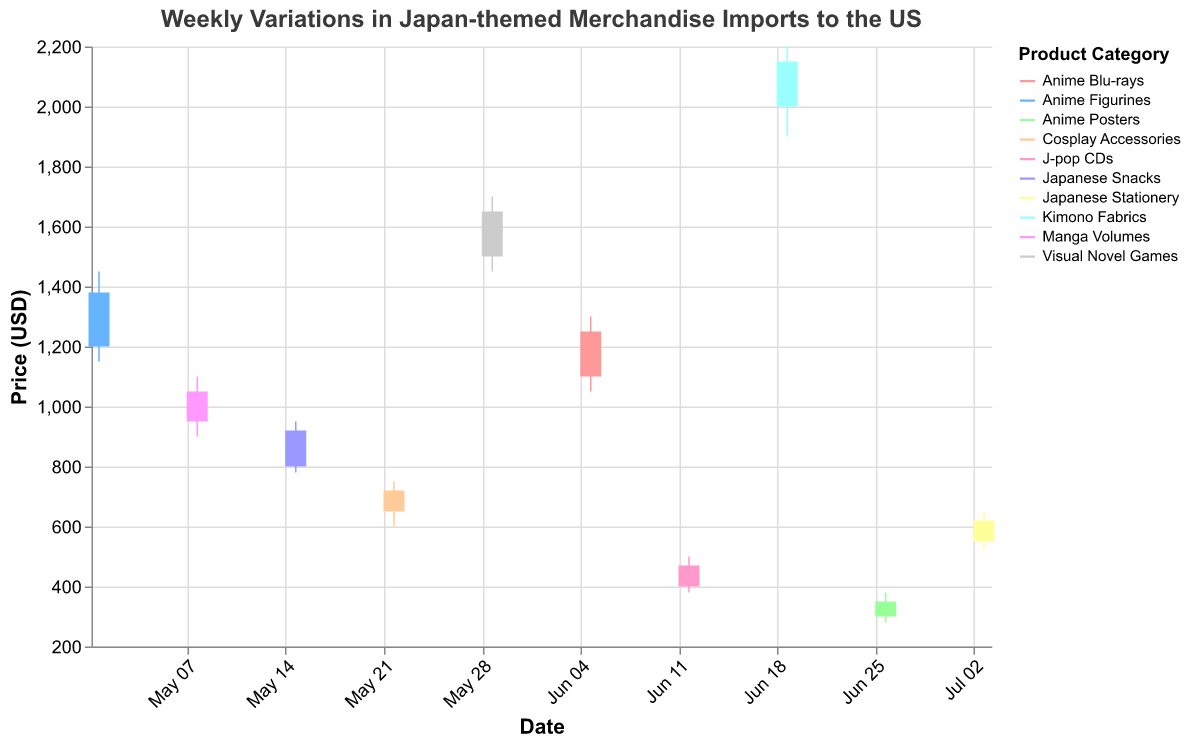What's the title of the figure? The title of the figure is displayed at the top. It reads "Weekly Variations in Japan-themed Merchandise Imports to the US."
Answer: Weekly Variations in Japan-themed Merchandise Imports to the US What is the price range of "Kimono Fabrics" from the data? The price range in an OHLC chart is calculated from the Low to High values. For "Kimono Fabrics" on 2023-06-19, the Low is 1900 USD and the High is 2200 USD.
Answer: 1900-2200 USD Which product category experienced the highest closing price? From the Close values in the data, the highest closing price belongs to "Kimono Fabrics" on 2023-06-19, which closed at 2150 USD.
Answer: Kimono Fabrics Comparing the "Visual Novel Games" and "J-pop CDs", which one had a greater increase in price from Open to Close? Visual Novel Games opened at 1500 and closed at 1650, making an increase of 150 (1650 - 1500). J-pop CDs opened at 400 and closed at 470, making an increase of 70 (470 - 400).
Answer: Visual Novel Games What was the lowest price recorded for "Anime Figurines"? For "Anime Figurines" which data is on 2023-05-01, the Low value indicates the lowest price, which is 1150 USD.
Answer: 1150 USD Which week experienced the highest overall price high (High value) among all categories? Looking at the High values in the data, "Kimono Fabrics" on 2023-06-19 had the highest value of 2200 USD.
Answer: 2023-06-19 What is the difference between the highest and lowest opening prices in the given data? The highest opening price is from "Kimono Fabrics" at 2000 USD, and the lowest opening price is from "Anime Posters" at 300 USD. The difference is 2000 - 300 = 1700.
Answer: 1700 USD Which product category had the smallest price range (difference between High and Low)? Calculate the price ranges for each category and find the smallest: 
- Anime Figurines: 1450 - 1150 = 300
- Manga Volumes: 1100 - 900 = 200
- Japanese Snacks: 950 - 780 = 170
- Cosplay Accessories: 750 - 600 = 150
- Visual Novel Games: 1700 - 1450 = 250
- Anime Blu-rays: 1300 - 1050 = 250
- J-pop CDs: 500 - 380 = 120
- Kimono Fabrics: 2200 - 1900 = 300
- Anime Posters: 380 - 280 = 100
- Japanese Stationery: 650 - 520 = 130
The smallest range is 100 for "Anime Posters".
Answer: Anime Posters 